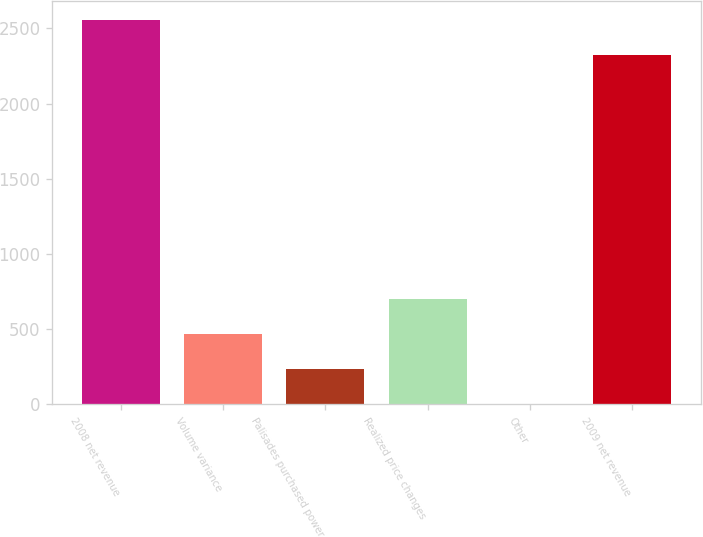Convert chart to OTSL. <chart><loc_0><loc_0><loc_500><loc_500><bar_chart><fcel>2008 net revenue<fcel>Volume variance<fcel>Palisades purchased power<fcel>Realized price changes<fcel>Other<fcel>2009 net revenue<nl><fcel>2556.2<fcel>468.4<fcel>235.2<fcel>701.6<fcel>2<fcel>2323<nl></chart> 